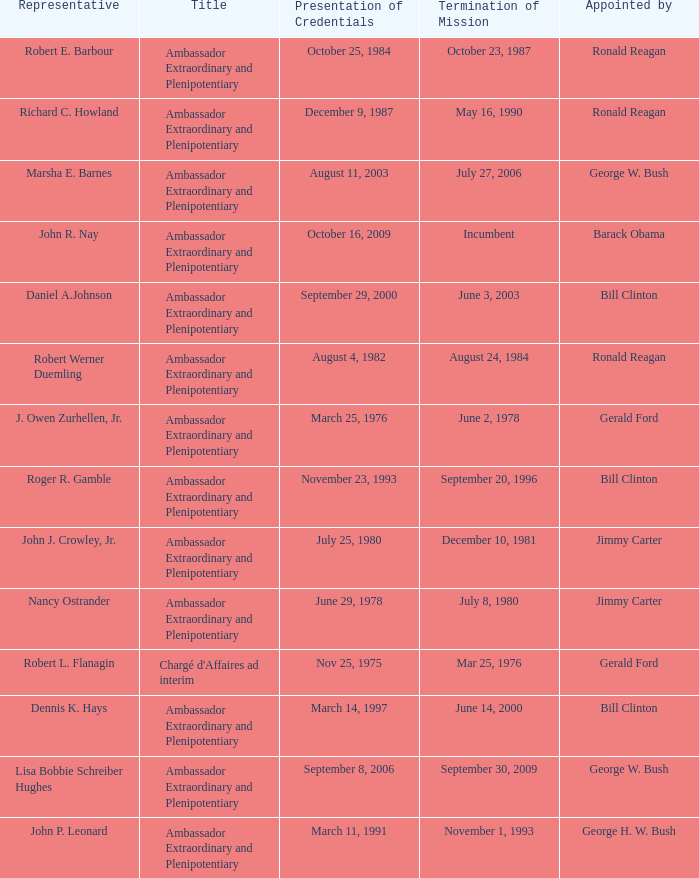What is the Termination of Mission date for Marsha E. Barnes, the Ambassador Extraordinary and Plenipotentiary? July 27, 2006. 